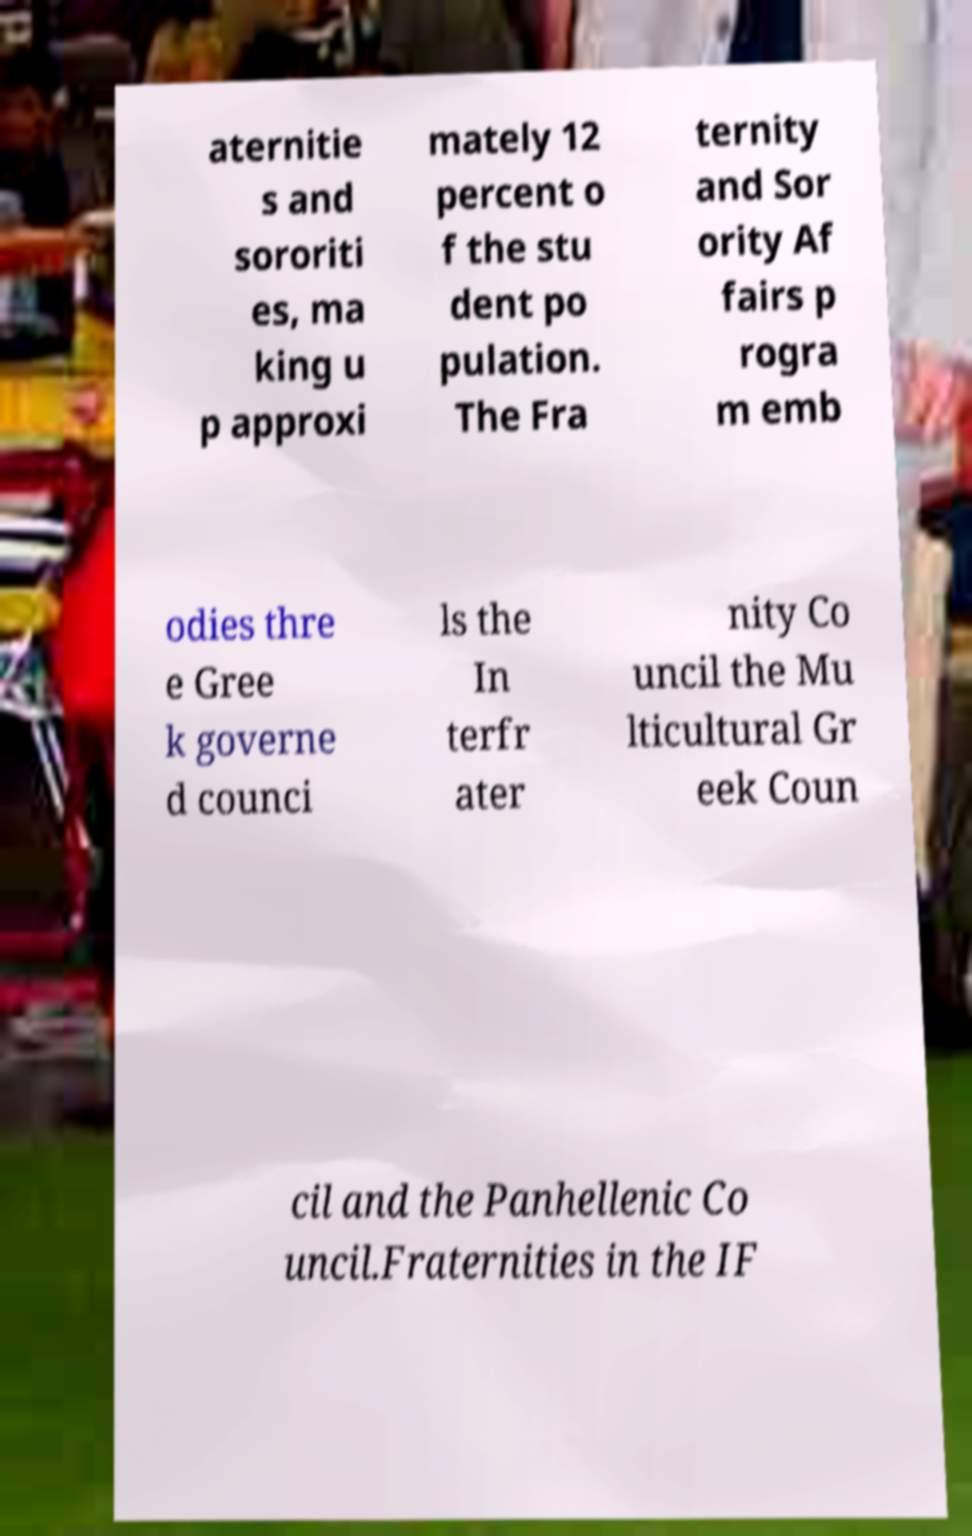Can you accurately transcribe the text from the provided image for me? aternitie s and sororiti es, ma king u p approxi mately 12 percent o f the stu dent po pulation. The Fra ternity and Sor ority Af fairs p rogra m emb odies thre e Gree k governe d counci ls the In terfr ater nity Co uncil the Mu lticultural Gr eek Coun cil and the Panhellenic Co uncil.Fraternities in the IF 